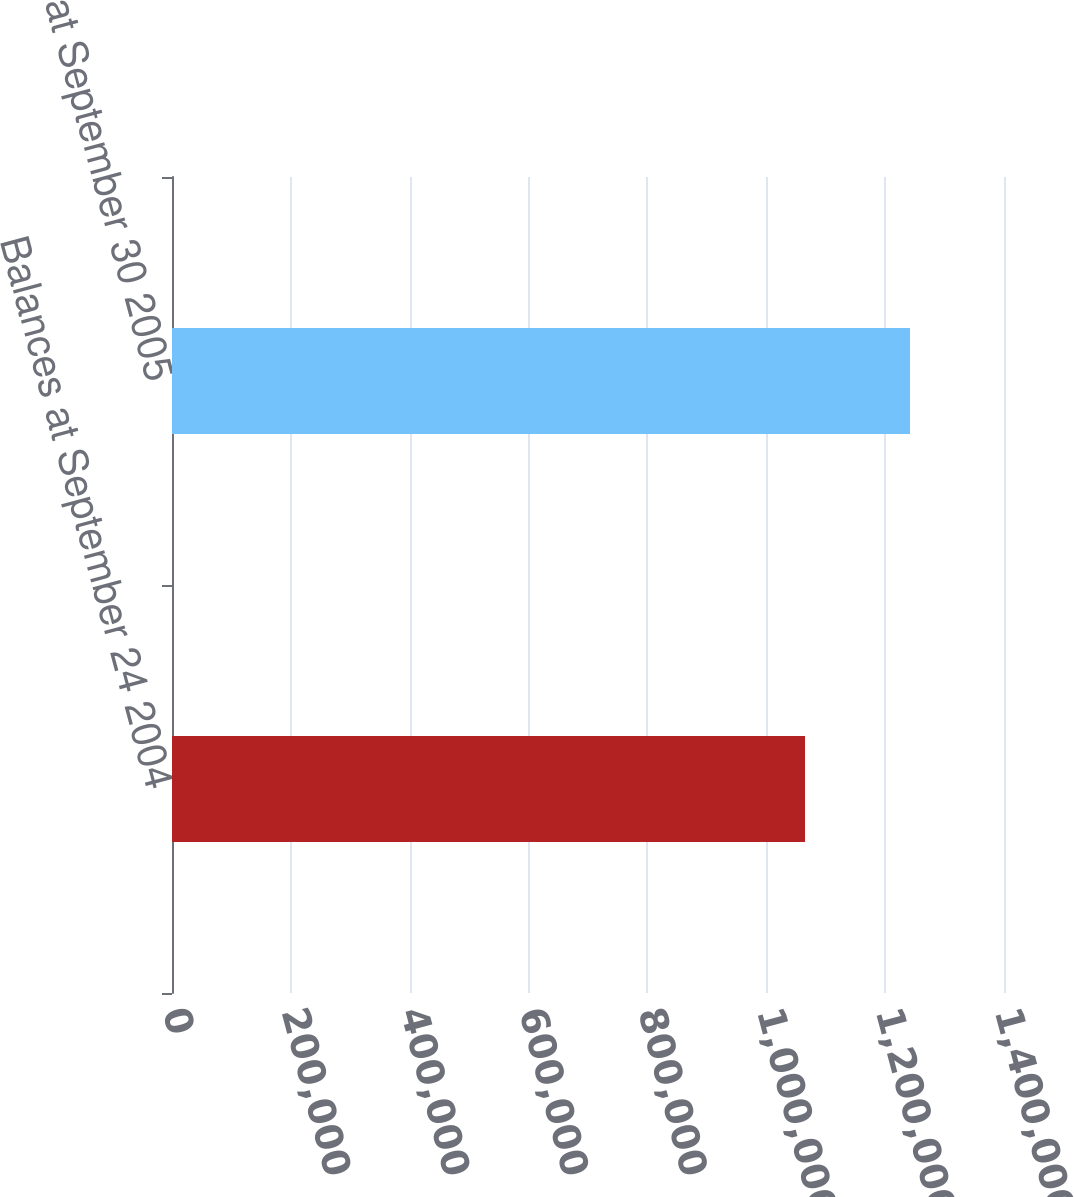<chart> <loc_0><loc_0><loc_500><loc_500><bar_chart><fcel>Balances at September 24 2004<fcel>Balances at September 30 2005<nl><fcel>1.06521e+06<fcel>1.24182e+06<nl></chart> 